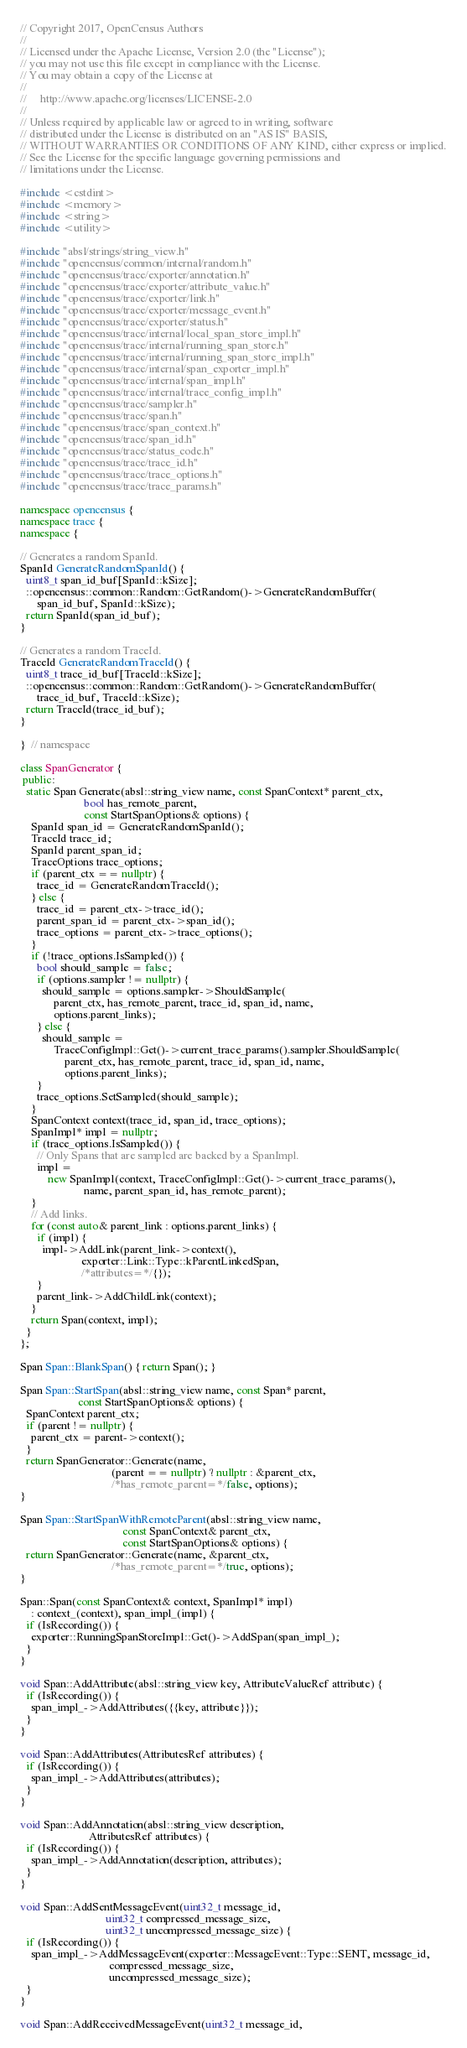<code> <loc_0><loc_0><loc_500><loc_500><_C++_>// Copyright 2017, OpenCensus Authors
//
// Licensed under the Apache License, Version 2.0 (the "License");
// you may not use this file except in compliance with the License.
// You may obtain a copy of the License at
//
//     http://www.apache.org/licenses/LICENSE-2.0
//
// Unless required by applicable law or agreed to in writing, software
// distributed under the License is distributed on an "AS IS" BASIS,
// WITHOUT WARRANTIES OR CONDITIONS OF ANY KIND, either express or implied.
// See the License for the specific language governing permissions and
// limitations under the License.

#include <cstdint>
#include <memory>
#include <string>
#include <utility>

#include "absl/strings/string_view.h"
#include "opencensus/common/internal/random.h"
#include "opencensus/trace/exporter/annotation.h"
#include "opencensus/trace/exporter/attribute_value.h"
#include "opencensus/trace/exporter/link.h"
#include "opencensus/trace/exporter/message_event.h"
#include "opencensus/trace/exporter/status.h"
#include "opencensus/trace/internal/local_span_store_impl.h"
#include "opencensus/trace/internal/running_span_store.h"
#include "opencensus/trace/internal/running_span_store_impl.h"
#include "opencensus/trace/internal/span_exporter_impl.h"
#include "opencensus/trace/internal/span_impl.h"
#include "opencensus/trace/internal/trace_config_impl.h"
#include "opencensus/trace/sampler.h"
#include "opencensus/trace/span.h"
#include "opencensus/trace/span_context.h"
#include "opencensus/trace/span_id.h"
#include "opencensus/trace/status_code.h"
#include "opencensus/trace/trace_id.h"
#include "opencensus/trace/trace_options.h"
#include "opencensus/trace/trace_params.h"

namespace opencensus {
namespace trace {
namespace {

// Generates a random SpanId.
SpanId GenerateRandomSpanId() {
  uint8_t span_id_buf[SpanId::kSize];
  ::opencensus::common::Random::GetRandom()->GenerateRandomBuffer(
      span_id_buf, SpanId::kSize);
  return SpanId(span_id_buf);
}

// Generates a random TraceId.
TraceId GenerateRandomTraceId() {
  uint8_t trace_id_buf[TraceId::kSize];
  ::opencensus::common::Random::GetRandom()->GenerateRandomBuffer(
      trace_id_buf, TraceId::kSize);
  return TraceId(trace_id_buf);
}

}  // namespace

class SpanGenerator {
 public:
  static Span Generate(absl::string_view name, const SpanContext* parent_ctx,
                       bool has_remote_parent,
                       const StartSpanOptions& options) {
    SpanId span_id = GenerateRandomSpanId();
    TraceId trace_id;
    SpanId parent_span_id;
    TraceOptions trace_options;
    if (parent_ctx == nullptr) {
      trace_id = GenerateRandomTraceId();
    } else {
      trace_id = parent_ctx->trace_id();
      parent_span_id = parent_ctx->span_id();
      trace_options = parent_ctx->trace_options();
    }
    if (!trace_options.IsSampled()) {
      bool should_sample = false;
      if (options.sampler != nullptr) {
        should_sample = options.sampler->ShouldSample(
            parent_ctx, has_remote_parent, trace_id, span_id, name,
            options.parent_links);
      } else {
        should_sample =
            TraceConfigImpl::Get()->current_trace_params().sampler.ShouldSample(
                parent_ctx, has_remote_parent, trace_id, span_id, name,
                options.parent_links);
      }
      trace_options.SetSampled(should_sample);
    }
    SpanContext context(trace_id, span_id, trace_options);
    SpanImpl* impl = nullptr;
    if (trace_options.IsSampled()) {
      // Only Spans that are sampled are backed by a SpanImpl.
      impl =
          new SpanImpl(context, TraceConfigImpl::Get()->current_trace_params(),
                       name, parent_span_id, has_remote_parent);
    }
    // Add links.
    for (const auto& parent_link : options.parent_links) {
      if (impl) {
        impl->AddLink(parent_link->context(),
                      exporter::Link::Type::kParentLinkedSpan,
                      /*attributes=*/{});
      }
      parent_link->AddChildLink(context);
    }
    return Span(context, impl);
  }
};

Span Span::BlankSpan() { return Span(); }

Span Span::StartSpan(absl::string_view name, const Span* parent,
                     const StartSpanOptions& options) {
  SpanContext parent_ctx;
  if (parent != nullptr) {
    parent_ctx = parent->context();
  }
  return SpanGenerator::Generate(name,
                                 (parent == nullptr) ? nullptr : &parent_ctx,
                                 /*has_remote_parent=*/false, options);
}

Span Span::StartSpanWithRemoteParent(absl::string_view name,
                                     const SpanContext& parent_ctx,
                                     const StartSpanOptions& options) {
  return SpanGenerator::Generate(name, &parent_ctx,
                                 /*has_remote_parent=*/true, options);
}

Span::Span(const SpanContext& context, SpanImpl* impl)
    : context_(context), span_impl_(impl) {
  if (IsRecording()) {
    exporter::RunningSpanStoreImpl::Get()->AddSpan(span_impl_);
  }
}

void Span::AddAttribute(absl::string_view key, AttributeValueRef attribute) {
  if (IsRecording()) {
    span_impl_->AddAttributes({{key, attribute}});
  }
}

void Span::AddAttributes(AttributesRef attributes) {
  if (IsRecording()) {
    span_impl_->AddAttributes(attributes);
  }
}

void Span::AddAnnotation(absl::string_view description,
                         AttributesRef attributes) {
  if (IsRecording()) {
    span_impl_->AddAnnotation(description, attributes);
  }
}

void Span::AddSentMessageEvent(uint32_t message_id,
                               uint32_t compressed_message_size,
                               uint32_t uncompressed_message_size) {
  if (IsRecording()) {
    span_impl_->AddMessageEvent(exporter::MessageEvent::Type::SENT, message_id,
                                compressed_message_size,
                                uncompressed_message_size);
  }
}

void Span::AddReceivedMessageEvent(uint32_t message_id,</code> 